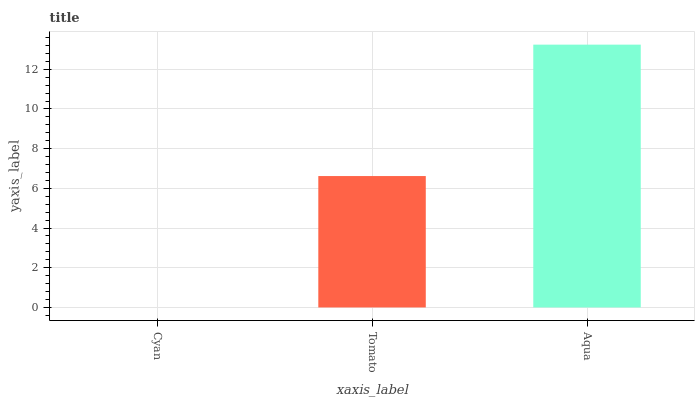Is Tomato the minimum?
Answer yes or no. No. Is Tomato the maximum?
Answer yes or no. No. Is Tomato greater than Cyan?
Answer yes or no. Yes. Is Cyan less than Tomato?
Answer yes or no. Yes. Is Cyan greater than Tomato?
Answer yes or no. No. Is Tomato less than Cyan?
Answer yes or no. No. Is Tomato the high median?
Answer yes or no. Yes. Is Tomato the low median?
Answer yes or no. Yes. Is Aqua the high median?
Answer yes or no. No. Is Aqua the low median?
Answer yes or no. No. 